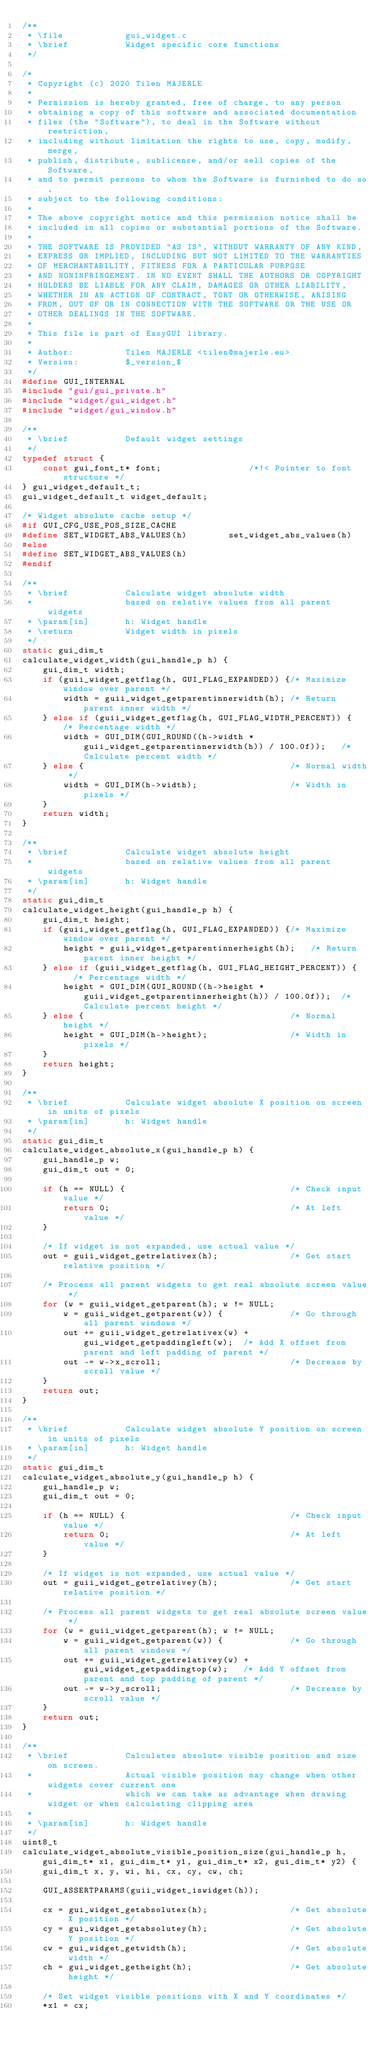<code> <loc_0><loc_0><loc_500><loc_500><_C_>/**	
 * \file            gui_widget.c
 * \brief           Widget specific core functions
 */
 
/*
 * Copyright (c) 2020 Tilen MAJERLE
 *  
 * Permission is hereby granted, free of charge, to any person
 * obtaining a copy of this software and associated documentation
 * files (the "Software"), to deal in the Software without restriction,
 * including without limitation the rights to use, copy, modify, merge,
 * publish, distribute, sublicense, and/or sell copies of the Software, 
 * and to permit persons to whom the Software is furnished to do so, 
 * subject to the following conditions:
 * 
 * The above copyright notice and this permission notice shall be
 * included in all copies or substantial portions of the Software.
 * 
 * THE SOFTWARE IS PROVIDED "AS IS", WITHOUT WARRANTY OF ANY KIND,
 * EXPRESS OR IMPLIED, INCLUDING BUT NOT LIMITED TO THE WARRANTIES
 * OF MERCHANTABILITY, FITNESS FOR A PARTICULAR PURPOSE
 * AND NONINFRINGEMENT. IN NO EVENT SHALL THE AUTHORS OR COPYRIGHT
 * HOLDERS BE LIABLE FOR ANY CLAIM, DAMAGES OR OTHER LIABILITY,
 * WHETHER IN AN ACTION OF CONTRACT, TORT OR OTHERWISE, ARISING 
 * FROM, OUT OF OR IN CONNECTION WITH THE SOFTWARE OR THE USE OR
 * OTHER DEALINGS IN THE SOFTWARE.
 *
 * This file is part of EasyGUI library.
 *
 * Author:          Tilen MAJERLE <tilen@majerle.eu>
 * Version:         $_version_$
 */
#define GUI_INTERNAL
#include "gui/gui_private.h"
#include "widget/gui_widget.h"
#include "widget/gui_window.h"

/**
 * \brief           Default widget settings
 */
typedef struct {
    const gui_font_t* font;                 /*!< Pointer to font structure */
} gui_widget_default_t;
gui_widget_default_t widget_default;

/* Widget absolute cache setup */
#if GUI_CFG_USE_POS_SIZE_CACHE
#define SET_WIDGET_ABS_VALUES(h)        set_widget_abs_values(h)
#else
#define SET_WIDGET_ABS_VALUES(h)
#endif

/**
 * \brief           Calculate widget absolute width
 *                  based on relative values from all parent widgets
 * \param[in]       h: Widget handle
 * \return          Widget width in pixels
 */
static gui_dim_t
calculate_widget_width(gui_handle_p h) {
    gui_dim_t width;
    if (guii_widget_getflag(h, GUI_FLAG_EXPANDED)) {/* Maximize window over parent */
        width = guii_widget_getparentinnerwidth(h); /* Return parent inner width */
    } else if (guii_widget_getflag(h, GUI_FLAG_WIDTH_PERCENT)) {   /* Percentage width */
        width = GUI_DIM(GUI_ROUND((h->width * guii_widget_getparentinnerwidth(h)) / 100.0f));   /* Calculate percent width */
    } else {                                        /* Normal width */
        width = GUI_DIM(h->width);                  /* Width in pixels */
    }
    return width;
}

/**
 * \brief           Calculate widget absolute height
 *                  based on relative values from all parent widgets
 * \param[in]       h: Widget handle
 */
static gui_dim_t
calculate_widget_height(gui_handle_p h) {
    gui_dim_t height;
    if (guii_widget_getflag(h, GUI_FLAG_EXPANDED)) {/* Maximize window over parent */
        height = guii_widget_getparentinnerheight(h);   /* Return parent inner height */
    } else if (guii_widget_getflag(h, GUI_FLAG_HEIGHT_PERCENT)) {   /* Percentage width */
        height = GUI_DIM(GUI_ROUND((h->height * guii_widget_getparentinnerheight(h)) / 100.0f));  /* Calculate percent height */
    } else {                                        /* Normal height */
        height = GUI_DIM(h->height);                /* Width in pixels */
    }
    return height;
}

/**
 * \brief           Calculate widget absolute X position on screen in units of pixels
 * \param[in]       h: Widget handle
 */
static gui_dim_t
calculate_widget_absolute_x(gui_handle_p h) {
    gui_handle_p w;
    gui_dim_t out = 0;
    
    if (h == NULL) {                                /* Check input value */
        return 0;                                   /* At left value */
    }
    
    /* If widget is not expanded, use actual value */
    out = guii_widget_getrelativex(h);              /* Get start relative position */
    
    /* Process all parent widgets to get real absolute screen value */
    for (w = guii_widget_getparent(h); w != NULL;
        w = guii_widget_getparent(w)) {             /* Go through all parent windows */
        out += guii_widget_getrelativex(w) + gui_widget_getpaddingleft(w);  /* Add X offset from parent and left padding of parent */
        out -= w->x_scroll;                         /* Decrease by scroll value */
    }
    return out;
}

/**
 * \brief           Calculate widget absolute Y position on screen in units of pixels
 * \param[in]       h: Widget handle
 */
static gui_dim_t
calculate_widget_absolute_y(gui_handle_p h) {
    gui_handle_p w;
    gui_dim_t out = 0;
    
    if (h == NULL) {                                /* Check input value */
        return 0;                                   /* At left value */
    }
    
    /* If widget is not expanded, use actual value */
    out = guii_widget_getrelativey(h);              /* Get start relative position */
    
    /* Process all parent widgets to get real absolute screen value */
    for (w = guii_widget_getparent(h); w != NULL;
        w = guii_widget_getparent(w)) {             /* Go through all parent windows */
        out += guii_widget_getrelativey(w) + gui_widget_getpaddingtop(w);   /* Add Y offset from parent and top padding of parent */
        out -= w->y_scroll;                         /* Decrease by scroll value */
    }
    return out;
}

/**
 * \brief           Calculates absolute visible position and size on screen.
 *                  Actual visible position may change when other widgets cover current one
 *                  which we can take as advantage when drawing widget or when calculating clipping area
 *
 * \param[in]       h: Widget handle
 */
uint8_t
calculate_widget_absolute_visible_position_size(gui_handle_p h, gui_dim_t* x1, gui_dim_t* y1, gui_dim_t* x2, gui_dim_t* y2) {
    gui_dim_t x, y, wi, hi, cx, cy, cw, ch;
    
    GUI_ASSERTPARAMS(guii_widget_iswidget(h));    
    
    cx = gui_widget_getabsolutex(h);                /* Get absolute X position */
    cy = gui_widget_getabsolutey(h);                /* Get absolute Y position */
    cw = gui_widget_getwidth(h);                    /* Get absolute width */
    ch = gui_widget_getheight(h);                   /* Get absolute height */
    
    /* Set widget visible positions with X and Y coordinates */
    *x1 = cx;</code> 